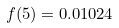Convert formula to latex. <formula><loc_0><loc_0><loc_500><loc_500>f ( 5 ) = 0 . 0 1 0 2 4</formula> 